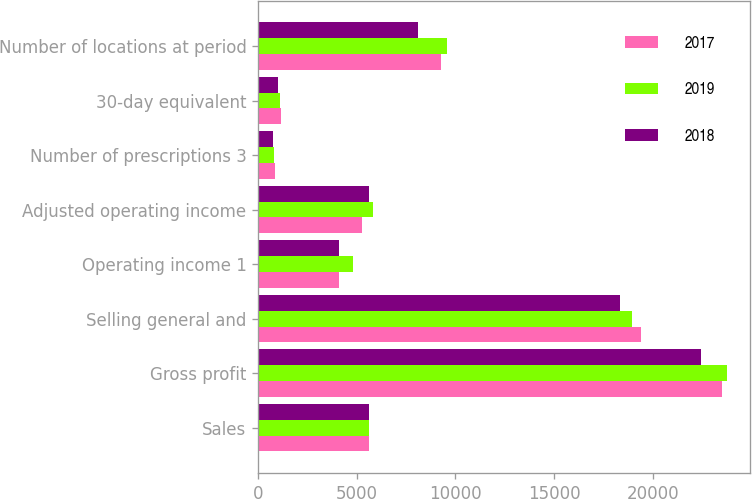Convert chart to OTSL. <chart><loc_0><loc_0><loc_500><loc_500><stacked_bar_chart><ecel><fcel>Sales<fcel>Gross profit<fcel>Selling general and<fcel>Operating income 1<fcel>Adjusted operating income<fcel>Number of prescriptions 3<fcel>30-day equivalent<fcel>Number of locations at period<nl><fcel>2017<fcel>5606<fcel>23511<fcel>19424<fcel>4088<fcel>5255<fcel>843.7<fcel>1150.1<fcel>9285<nl><fcel>2019<fcel>5606<fcel>23758<fcel>18971<fcel>4787<fcel>5814<fcel>823.1<fcel>1094.4<fcel>9569<nl><fcel>2018<fcel>5606<fcel>22450<fcel>18356<fcel>4094<fcel>5606<fcel>764.4<fcel>989.7<fcel>8109<nl></chart> 